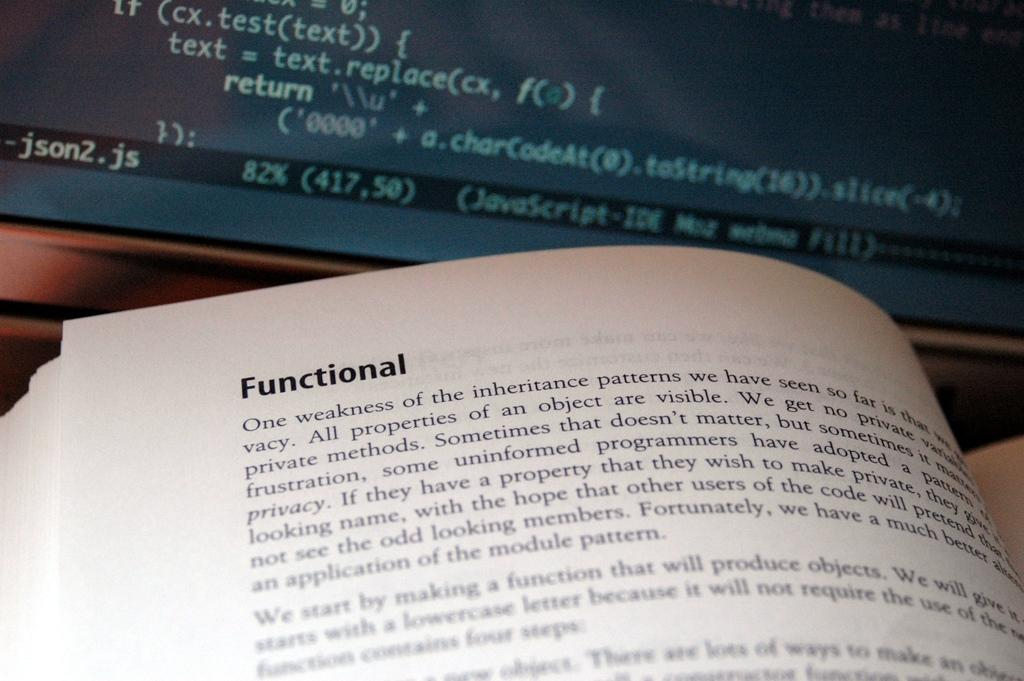<image>
Describe the image concisely. Book open on a page that says Functional on top. 